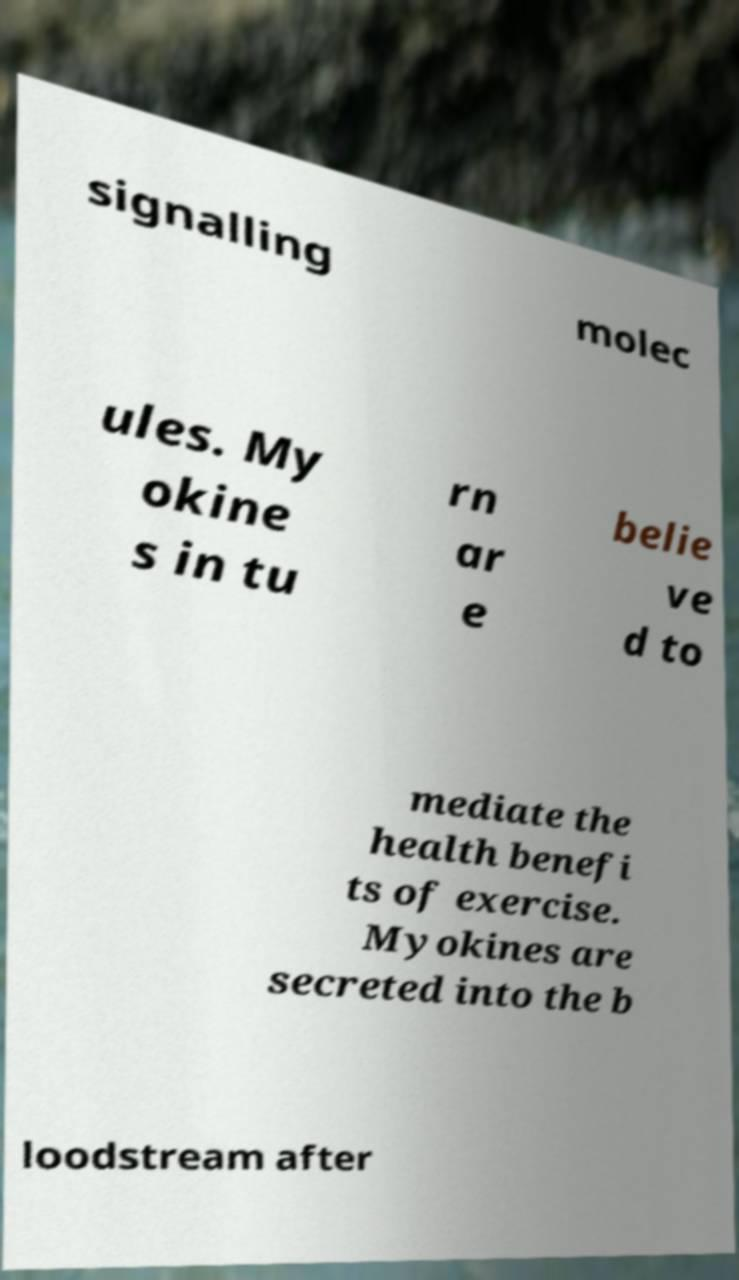Could you extract and type out the text from this image? signalling molec ules. My okine s in tu rn ar e belie ve d to mediate the health benefi ts of exercise. Myokines are secreted into the b loodstream after 